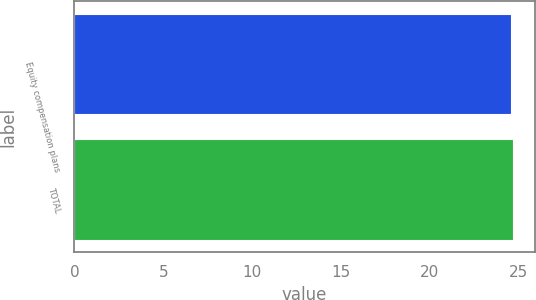Convert chart. <chart><loc_0><loc_0><loc_500><loc_500><bar_chart><fcel>Equity compensation plans<fcel>TOTAL<nl><fcel>24.58<fcel>24.68<nl></chart> 